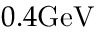<formula> <loc_0><loc_0><loc_500><loc_500>0 . 4 G e V</formula> 